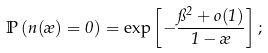Convert formula to latex. <formula><loc_0><loc_0><loc_500><loc_500>\mathbb { P } \left ( n ( \rho ) = 0 \right ) = \exp \left [ - \frac { \pi ^ { 2 } + o ( 1 ) } { 1 - \rho } \right ] ;</formula> 